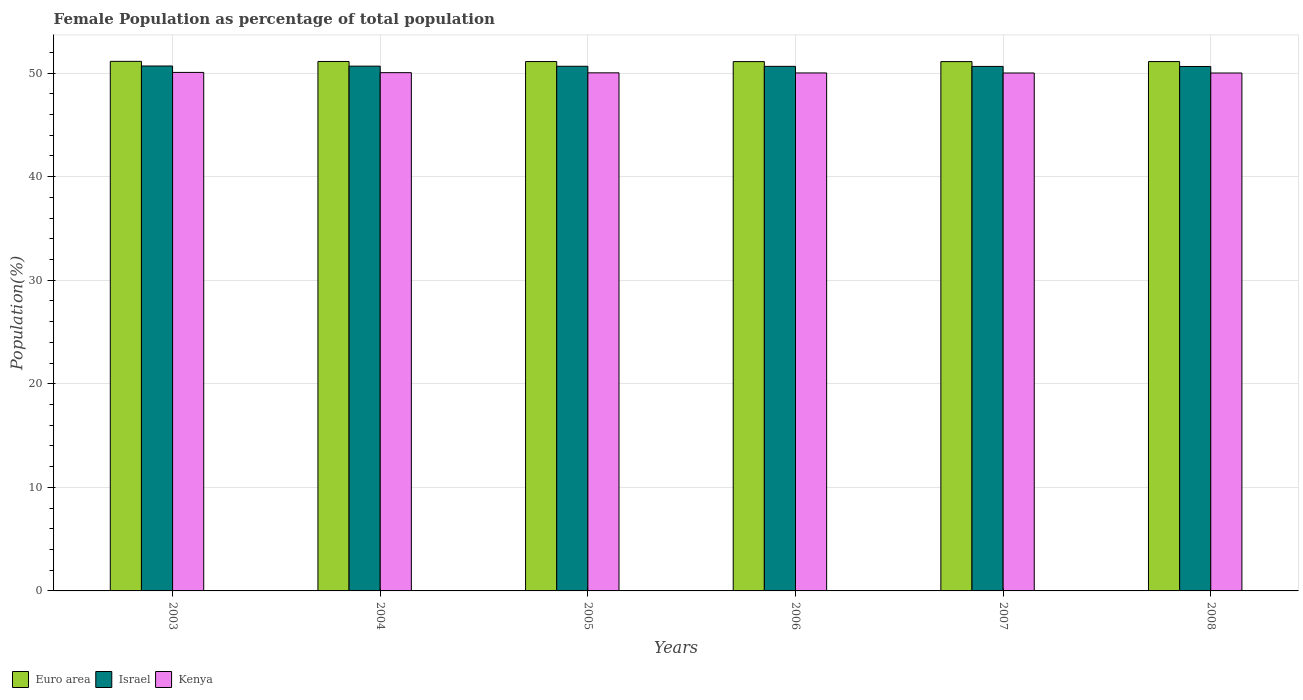How many groups of bars are there?
Your answer should be compact. 6. How many bars are there on the 3rd tick from the left?
Give a very brief answer. 3. How many bars are there on the 6th tick from the right?
Ensure brevity in your answer.  3. What is the female population in in Israel in 2004?
Your answer should be compact. 50.67. Across all years, what is the maximum female population in in Euro area?
Offer a very short reply. 51.14. Across all years, what is the minimum female population in in Israel?
Make the answer very short. 50.64. In which year was the female population in in Kenya maximum?
Your answer should be very brief. 2003. What is the total female population in in Kenya in the graph?
Ensure brevity in your answer.  300.18. What is the difference between the female population in in Kenya in 2003 and that in 2008?
Ensure brevity in your answer.  0.06. What is the difference between the female population in in Israel in 2003 and the female population in in Euro area in 2006?
Your answer should be compact. -0.43. What is the average female population in in Kenya per year?
Keep it short and to the point. 50.03. In the year 2007, what is the difference between the female population in in Kenya and female population in in Israel?
Provide a short and direct response. -0.64. In how many years, is the female population in in Israel greater than 6 %?
Offer a terse response. 6. What is the ratio of the female population in in Kenya in 2005 to that in 2007?
Your answer should be compact. 1. What is the difference between the highest and the second highest female population in in Euro area?
Your answer should be very brief. 0.01. What is the difference between the highest and the lowest female population in in Euro area?
Your response must be concise. 0.02. What does the 1st bar from the left in 2005 represents?
Your response must be concise. Euro area. What does the 1st bar from the right in 2003 represents?
Your answer should be very brief. Kenya. Is it the case that in every year, the sum of the female population in in Israel and female population in in Euro area is greater than the female population in in Kenya?
Provide a succinct answer. Yes. How many bars are there?
Offer a very short reply. 18. Are all the bars in the graph horizontal?
Offer a terse response. No. How many years are there in the graph?
Offer a terse response. 6. What is the difference between two consecutive major ticks on the Y-axis?
Provide a succinct answer. 10. Are the values on the major ticks of Y-axis written in scientific E-notation?
Make the answer very short. No. Where does the legend appear in the graph?
Your answer should be compact. Bottom left. How many legend labels are there?
Ensure brevity in your answer.  3. How are the legend labels stacked?
Your answer should be very brief. Horizontal. What is the title of the graph?
Keep it short and to the point. Female Population as percentage of total population. Does "Mongolia" appear as one of the legend labels in the graph?
Your response must be concise. No. What is the label or title of the X-axis?
Offer a terse response. Years. What is the label or title of the Y-axis?
Give a very brief answer. Population(%). What is the Population(%) in Euro area in 2003?
Make the answer very short. 51.14. What is the Population(%) of Israel in 2003?
Your answer should be compact. 50.69. What is the Population(%) in Kenya in 2003?
Your answer should be compact. 50.07. What is the Population(%) in Euro area in 2004?
Your response must be concise. 51.12. What is the Population(%) in Israel in 2004?
Ensure brevity in your answer.  50.67. What is the Population(%) of Kenya in 2004?
Provide a short and direct response. 50.04. What is the Population(%) in Euro area in 2005?
Offer a very short reply. 51.12. What is the Population(%) of Israel in 2005?
Offer a terse response. 50.66. What is the Population(%) in Kenya in 2005?
Your answer should be very brief. 50.03. What is the Population(%) of Euro area in 2006?
Keep it short and to the point. 51.11. What is the Population(%) of Israel in 2006?
Provide a short and direct response. 50.65. What is the Population(%) of Kenya in 2006?
Your response must be concise. 50.02. What is the Population(%) of Euro area in 2007?
Give a very brief answer. 51.11. What is the Population(%) of Israel in 2007?
Your response must be concise. 50.65. What is the Population(%) in Kenya in 2007?
Ensure brevity in your answer.  50.01. What is the Population(%) in Euro area in 2008?
Offer a terse response. 51.12. What is the Population(%) in Israel in 2008?
Provide a short and direct response. 50.64. What is the Population(%) of Kenya in 2008?
Offer a very short reply. 50.01. Across all years, what is the maximum Population(%) of Euro area?
Give a very brief answer. 51.14. Across all years, what is the maximum Population(%) in Israel?
Provide a succinct answer. 50.69. Across all years, what is the maximum Population(%) in Kenya?
Keep it short and to the point. 50.07. Across all years, what is the minimum Population(%) of Euro area?
Make the answer very short. 51.11. Across all years, what is the minimum Population(%) in Israel?
Give a very brief answer. 50.64. Across all years, what is the minimum Population(%) in Kenya?
Your answer should be compact. 50.01. What is the total Population(%) in Euro area in the graph?
Make the answer very short. 306.72. What is the total Population(%) in Israel in the graph?
Provide a succinct answer. 303.97. What is the total Population(%) in Kenya in the graph?
Your answer should be compact. 300.18. What is the difference between the Population(%) in Euro area in 2003 and that in 2004?
Your answer should be very brief. 0.01. What is the difference between the Population(%) in Israel in 2003 and that in 2004?
Give a very brief answer. 0.01. What is the difference between the Population(%) of Kenya in 2003 and that in 2004?
Provide a succinct answer. 0.02. What is the difference between the Population(%) of Euro area in 2003 and that in 2005?
Offer a very short reply. 0.02. What is the difference between the Population(%) in Israel in 2003 and that in 2005?
Ensure brevity in your answer.  0.03. What is the difference between the Population(%) of Kenya in 2003 and that in 2005?
Offer a terse response. 0.04. What is the difference between the Population(%) in Euro area in 2003 and that in 2006?
Give a very brief answer. 0.02. What is the difference between the Population(%) of Israel in 2003 and that in 2006?
Offer a very short reply. 0.03. What is the difference between the Population(%) of Kenya in 2003 and that in 2006?
Offer a very short reply. 0.05. What is the difference between the Population(%) in Euro area in 2003 and that in 2007?
Your answer should be very brief. 0.02. What is the difference between the Population(%) in Israel in 2003 and that in 2007?
Offer a very short reply. 0.04. What is the difference between the Population(%) of Kenya in 2003 and that in 2007?
Make the answer very short. 0.06. What is the difference between the Population(%) in Euro area in 2003 and that in 2008?
Provide a succinct answer. 0.02. What is the difference between the Population(%) of Israel in 2003 and that in 2008?
Offer a terse response. 0.05. What is the difference between the Population(%) of Kenya in 2003 and that in 2008?
Your answer should be very brief. 0.06. What is the difference between the Population(%) of Euro area in 2004 and that in 2005?
Provide a short and direct response. 0.01. What is the difference between the Population(%) in Israel in 2004 and that in 2005?
Make the answer very short. 0.01. What is the difference between the Population(%) in Kenya in 2004 and that in 2005?
Give a very brief answer. 0.02. What is the difference between the Population(%) in Euro area in 2004 and that in 2006?
Your answer should be compact. 0.01. What is the difference between the Population(%) in Israel in 2004 and that in 2006?
Provide a short and direct response. 0.02. What is the difference between the Population(%) in Kenya in 2004 and that in 2006?
Provide a short and direct response. 0.03. What is the difference between the Population(%) of Euro area in 2004 and that in 2007?
Provide a succinct answer. 0.01. What is the difference between the Population(%) of Israel in 2004 and that in 2007?
Offer a very short reply. 0.03. What is the difference between the Population(%) in Kenya in 2004 and that in 2007?
Your answer should be very brief. 0.03. What is the difference between the Population(%) in Euro area in 2004 and that in 2008?
Offer a terse response. 0.01. What is the difference between the Population(%) of Israel in 2004 and that in 2008?
Ensure brevity in your answer.  0.03. What is the difference between the Population(%) of Kenya in 2004 and that in 2008?
Your response must be concise. 0.03. What is the difference between the Population(%) of Euro area in 2005 and that in 2006?
Make the answer very short. 0. What is the difference between the Population(%) of Israel in 2005 and that in 2006?
Offer a terse response. 0.01. What is the difference between the Population(%) of Kenya in 2005 and that in 2006?
Ensure brevity in your answer.  0.01. What is the difference between the Population(%) of Euro area in 2005 and that in 2007?
Offer a very short reply. 0. What is the difference between the Population(%) of Israel in 2005 and that in 2007?
Provide a succinct answer. 0.01. What is the difference between the Population(%) in Kenya in 2005 and that in 2007?
Your response must be concise. 0.01. What is the difference between the Population(%) in Euro area in 2005 and that in 2008?
Your answer should be compact. 0. What is the difference between the Population(%) of Israel in 2005 and that in 2008?
Your answer should be very brief. 0.02. What is the difference between the Population(%) in Kenya in 2005 and that in 2008?
Your answer should be very brief. 0.02. What is the difference between the Population(%) in Euro area in 2006 and that in 2007?
Make the answer very short. 0. What is the difference between the Population(%) in Israel in 2006 and that in 2007?
Ensure brevity in your answer.  0.01. What is the difference between the Population(%) in Kenya in 2006 and that in 2007?
Ensure brevity in your answer.  0. What is the difference between the Population(%) in Euro area in 2006 and that in 2008?
Your answer should be compact. -0. What is the difference between the Population(%) in Israel in 2006 and that in 2008?
Provide a succinct answer. 0.01. What is the difference between the Population(%) in Kenya in 2006 and that in 2008?
Your answer should be compact. 0.01. What is the difference between the Population(%) of Euro area in 2007 and that in 2008?
Make the answer very short. -0. What is the difference between the Population(%) in Israel in 2007 and that in 2008?
Your response must be concise. 0.01. What is the difference between the Population(%) in Kenya in 2007 and that in 2008?
Keep it short and to the point. 0. What is the difference between the Population(%) of Euro area in 2003 and the Population(%) of Israel in 2004?
Your response must be concise. 0.46. What is the difference between the Population(%) of Euro area in 2003 and the Population(%) of Kenya in 2004?
Make the answer very short. 1.09. What is the difference between the Population(%) in Israel in 2003 and the Population(%) in Kenya in 2004?
Provide a succinct answer. 0.64. What is the difference between the Population(%) of Euro area in 2003 and the Population(%) of Israel in 2005?
Offer a very short reply. 0.47. What is the difference between the Population(%) in Euro area in 2003 and the Population(%) in Kenya in 2005?
Your response must be concise. 1.11. What is the difference between the Population(%) in Israel in 2003 and the Population(%) in Kenya in 2005?
Give a very brief answer. 0.66. What is the difference between the Population(%) of Euro area in 2003 and the Population(%) of Israel in 2006?
Ensure brevity in your answer.  0.48. What is the difference between the Population(%) of Euro area in 2003 and the Population(%) of Kenya in 2006?
Your response must be concise. 1.12. What is the difference between the Population(%) of Israel in 2003 and the Population(%) of Kenya in 2006?
Keep it short and to the point. 0.67. What is the difference between the Population(%) of Euro area in 2003 and the Population(%) of Israel in 2007?
Keep it short and to the point. 0.49. What is the difference between the Population(%) in Euro area in 2003 and the Population(%) in Kenya in 2007?
Your answer should be very brief. 1.12. What is the difference between the Population(%) of Israel in 2003 and the Population(%) of Kenya in 2007?
Your answer should be very brief. 0.67. What is the difference between the Population(%) in Euro area in 2003 and the Population(%) in Israel in 2008?
Make the answer very short. 0.49. What is the difference between the Population(%) of Euro area in 2003 and the Population(%) of Kenya in 2008?
Ensure brevity in your answer.  1.12. What is the difference between the Population(%) in Israel in 2003 and the Population(%) in Kenya in 2008?
Your answer should be very brief. 0.68. What is the difference between the Population(%) in Euro area in 2004 and the Population(%) in Israel in 2005?
Make the answer very short. 0.46. What is the difference between the Population(%) of Euro area in 2004 and the Population(%) of Kenya in 2005?
Offer a very short reply. 1.1. What is the difference between the Population(%) of Israel in 2004 and the Population(%) of Kenya in 2005?
Offer a very short reply. 0.65. What is the difference between the Population(%) of Euro area in 2004 and the Population(%) of Israel in 2006?
Provide a succinct answer. 0.47. What is the difference between the Population(%) in Euro area in 2004 and the Population(%) in Kenya in 2006?
Your response must be concise. 1.11. What is the difference between the Population(%) in Israel in 2004 and the Population(%) in Kenya in 2006?
Ensure brevity in your answer.  0.66. What is the difference between the Population(%) in Euro area in 2004 and the Population(%) in Israel in 2007?
Provide a short and direct response. 0.48. What is the difference between the Population(%) in Euro area in 2004 and the Population(%) in Kenya in 2007?
Provide a succinct answer. 1.11. What is the difference between the Population(%) of Israel in 2004 and the Population(%) of Kenya in 2007?
Provide a succinct answer. 0.66. What is the difference between the Population(%) in Euro area in 2004 and the Population(%) in Israel in 2008?
Offer a very short reply. 0.48. What is the difference between the Population(%) of Euro area in 2004 and the Population(%) of Kenya in 2008?
Your response must be concise. 1.11. What is the difference between the Population(%) of Israel in 2004 and the Population(%) of Kenya in 2008?
Offer a terse response. 0.66. What is the difference between the Population(%) in Euro area in 2005 and the Population(%) in Israel in 2006?
Keep it short and to the point. 0.46. What is the difference between the Population(%) in Euro area in 2005 and the Population(%) in Kenya in 2006?
Provide a succinct answer. 1.1. What is the difference between the Population(%) of Israel in 2005 and the Population(%) of Kenya in 2006?
Ensure brevity in your answer.  0.64. What is the difference between the Population(%) of Euro area in 2005 and the Population(%) of Israel in 2007?
Your response must be concise. 0.47. What is the difference between the Population(%) of Euro area in 2005 and the Population(%) of Kenya in 2007?
Provide a short and direct response. 1.1. What is the difference between the Population(%) of Israel in 2005 and the Population(%) of Kenya in 2007?
Provide a succinct answer. 0.65. What is the difference between the Population(%) in Euro area in 2005 and the Population(%) in Israel in 2008?
Ensure brevity in your answer.  0.47. What is the difference between the Population(%) of Euro area in 2005 and the Population(%) of Kenya in 2008?
Your answer should be compact. 1.11. What is the difference between the Population(%) of Israel in 2005 and the Population(%) of Kenya in 2008?
Give a very brief answer. 0.65. What is the difference between the Population(%) in Euro area in 2006 and the Population(%) in Israel in 2007?
Make the answer very short. 0.47. What is the difference between the Population(%) in Euro area in 2006 and the Population(%) in Kenya in 2007?
Ensure brevity in your answer.  1.1. What is the difference between the Population(%) of Israel in 2006 and the Population(%) of Kenya in 2007?
Your response must be concise. 0.64. What is the difference between the Population(%) of Euro area in 2006 and the Population(%) of Israel in 2008?
Offer a very short reply. 0.47. What is the difference between the Population(%) of Euro area in 2006 and the Population(%) of Kenya in 2008?
Keep it short and to the point. 1.1. What is the difference between the Population(%) of Israel in 2006 and the Population(%) of Kenya in 2008?
Give a very brief answer. 0.64. What is the difference between the Population(%) of Euro area in 2007 and the Population(%) of Israel in 2008?
Keep it short and to the point. 0.47. What is the difference between the Population(%) of Euro area in 2007 and the Population(%) of Kenya in 2008?
Provide a short and direct response. 1.1. What is the difference between the Population(%) of Israel in 2007 and the Population(%) of Kenya in 2008?
Keep it short and to the point. 0.64. What is the average Population(%) of Euro area per year?
Provide a succinct answer. 51.12. What is the average Population(%) of Israel per year?
Provide a short and direct response. 50.66. What is the average Population(%) in Kenya per year?
Make the answer very short. 50.03. In the year 2003, what is the difference between the Population(%) in Euro area and Population(%) in Israel?
Offer a terse response. 0.45. In the year 2003, what is the difference between the Population(%) of Euro area and Population(%) of Kenya?
Your response must be concise. 1.07. In the year 2003, what is the difference between the Population(%) of Israel and Population(%) of Kenya?
Ensure brevity in your answer.  0.62. In the year 2004, what is the difference between the Population(%) of Euro area and Population(%) of Israel?
Make the answer very short. 0.45. In the year 2004, what is the difference between the Population(%) in Israel and Population(%) in Kenya?
Offer a very short reply. 0.63. In the year 2005, what is the difference between the Population(%) in Euro area and Population(%) in Israel?
Offer a very short reply. 0.46. In the year 2005, what is the difference between the Population(%) in Euro area and Population(%) in Kenya?
Offer a terse response. 1.09. In the year 2005, what is the difference between the Population(%) in Israel and Population(%) in Kenya?
Offer a terse response. 0.63. In the year 2006, what is the difference between the Population(%) in Euro area and Population(%) in Israel?
Offer a terse response. 0.46. In the year 2006, what is the difference between the Population(%) in Euro area and Population(%) in Kenya?
Your answer should be compact. 1.1. In the year 2006, what is the difference between the Population(%) of Israel and Population(%) of Kenya?
Offer a terse response. 0.64. In the year 2007, what is the difference between the Population(%) of Euro area and Population(%) of Israel?
Your answer should be very brief. 0.46. In the year 2007, what is the difference between the Population(%) in Euro area and Population(%) in Kenya?
Offer a very short reply. 1.1. In the year 2007, what is the difference between the Population(%) in Israel and Population(%) in Kenya?
Your answer should be very brief. 0.64. In the year 2008, what is the difference between the Population(%) of Euro area and Population(%) of Israel?
Your answer should be very brief. 0.47. In the year 2008, what is the difference between the Population(%) of Euro area and Population(%) of Kenya?
Offer a very short reply. 1.1. In the year 2008, what is the difference between the Population(%) of Israel and Population(%) of Kenya?
Keep it short and to the point. 0.63. What is the ratio of the Population(%) in Kenya in 2003 to that in 2005?
Offer a terse response. 1. What is the ratio of the Population(%) of Kenya in 2003 to that in 2006?
Your answer should be very brief. 1. What is the ratio of the Population(%) of Euro area in 2003 to that in 2007?
Offer a terse response. 1. What is the ratio of the Population(%) of Kenya in 2003 to that in 2007?
Provide a short and direct response. 1. What is the ratio of the Population(%) in Euro area in 2003 to that in 2008?
Ensure brevity in your answer.  1. What is the ratio of the Population(%) in Israel in 2003 to that in 2008?
Your answer should be very brief. 1. What is the ratio of the Population(%) of Israel in 2004 to that in 2005?
Your answer should be compact. 1. What is the ratio of the Population(%) in Kenya in 2004 to that in 2005?
Keep it short and to the point. 1. What is the ratio of the Population(%) in Israel in 2004 to that in 2006?
Offer a very short reply. 1. What is the ratio of the Population(%) in Euro area in 2004 to that in 2007?
Offer a very short reply. 1. What is the ratio of the Population(%) of Israel in 2004 to that in 2007?
Your response must be concise. 1. What is the ratio of the Population(%) in Israel in 2004 to that in 2008?
Your answer should be very brief. 1. What is the ratio of the Population(%) of Kenya in 2004 to that in 2008?
Offer a very short reply. 1. What is the ratio of the Population(%) in Euro area in 2005 to that in 2006?
Offer a very short reply. 1. What is the ratio of the Population(%) in Kenya in 2005 to that in 2006?
Your answer should be very brief. 1. What is the ratio of the Population(%) of Euro area in 2005 to that in 2007?
Provide a succinct answer. 1. What is the ratio of the Population(%) of Euro area in 2005 to that in 2008?
Your response must be concise. 1. What is the ratio of the Population(%) in Euro area in 2006 to that in 2007?
Keep it short and to the point. 1. What is the ratio of the Population(%) of Israel in 2006 to that in 2007?
Provide a succinct answer. 1. What is the ratio of the Population(%) in Euro area in 2006 to that in 2008?
Your response must be concise. 1. What is the ratio of the Population(%) in Kenya in 2006 to that in 2008?
Your answer should be compact. 1. What is the ratio of the Population(%) in Israel in 2007 to that in 2008?
Provide a short and direct response. 1. What is the ratio of the Population(%) of Kenya in 2007 to that in 2008?
Give a very brief answer. 1. What is the difference between the highest and the second highest Population(%) in Euro area?
Your answer should be very brief. 0.01. What is the difference between the highest and the second highest Population(%) in Israel?
Offer a terse response. 0.01. What is the difference between the highest and the second highest Population(%) of Kenya?
Offer a very short reply. 0.02. What is the difference between the highest and the lowest Population(%) in Euro area?
Keep it short and to the point. 0.02. What is the difference between the highest and the lowest Population(%) in Israel?
Provide a short and direct response. 0.05. What is the difference between the highest and the lowest Population(%) in Kenya?
Provide a succinct answer. 0.06. 